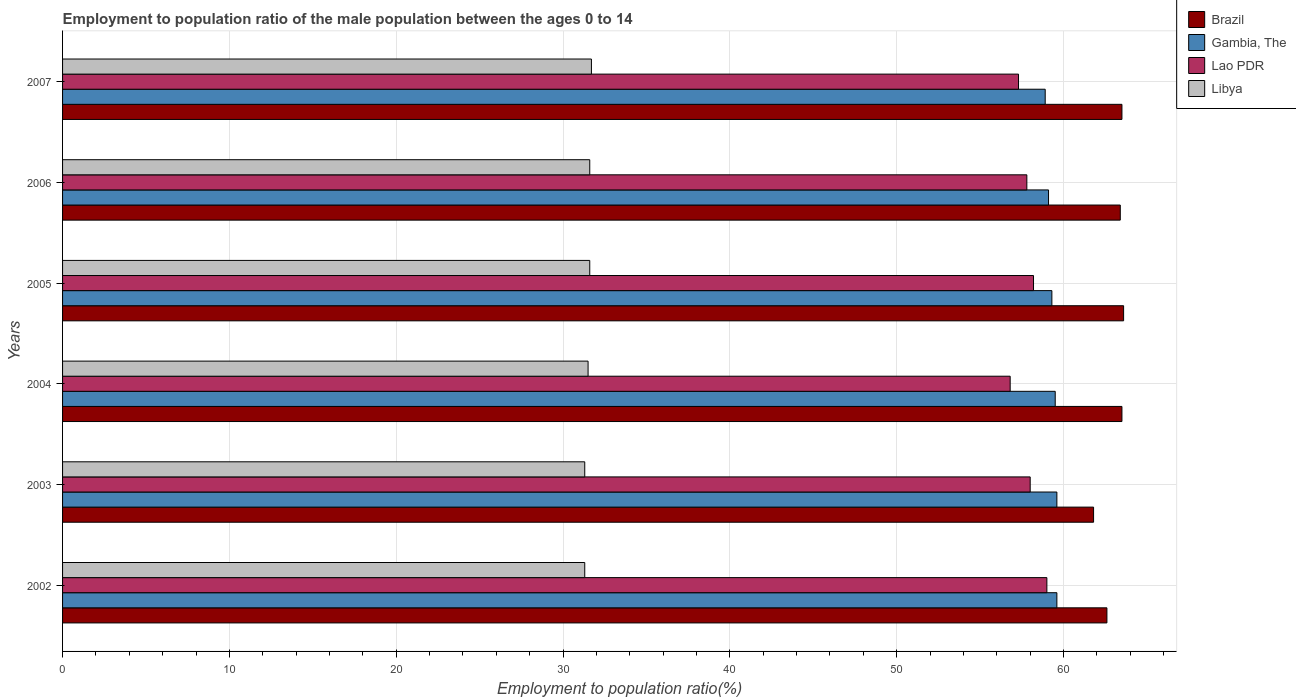How many groups of bars are there?
Your answer should be very brief. 6. How many bars are there on the 6th tick from the top?
Your response must be concise. 4. How many bars are there on the 5th tick from the bottom?
Make the answer very short. 4. What is the label of the 3rd group of bars from the top?
Your answer should be compact. 2005. What is the employment to population ratio in Gambia, The in 2005?
Your response must be concise. 59.3. Across all years, what is the maximum employment to population ratio in Brazil?
Offer a terse response. 63.6. Across all years, what is the minimum employment to population ratio in Libya?
Your answer should be compact. 31.3. What is the total employment to population ratio in Lao PDR in the graph?
Ensure brevity in your answer.  347.1. What is the difference between the employment to population ratio in Lao PDR in 2002 and that in 2004?
Provide a short and direct response. 2.2. What is the difference between the employment to population ratio in Lao PDR in 2004 and the employment to population ratio in Libya in 2007?
Ensure brevity in your answer.  25.1. What is the average employment to population ratio in Brazil per year?
Give a very brief answer. 63.07. What is the ratio of the employment to population ratio in Brazil in 2003 to that in 2005?
Your answer should be compact. 0.97. Is the employment to population ratio in Gambia, The in 2002 less than that in 2003?
Your answer should be very brief. No. Is the difference between the employment to population ratio in Brazil in 2003 and 2007 greater than the difference between the employment to population ratio in Gambia, The in 2003 and 2007?
Keep it short and to the point. No. What is the difference between the highest and the second highest employment to population ratio in Brazil?
Give a very brief answer. 0.1. What is the difference between the highest and the lowest employment to population ratio in Lao PDR?
Keep it short and to the point. 2.2. What does the 3rd bar from the top in 2007 represents?
Provide a succinct answer. Gambia, The. What does the 4th bar from the bottom in 2006 represents?
Give a very brief answer. Libya. Is it the case that in every year, the sum of the employment to population ratio in Brazil and employment to population ratio in Lao PDR is greater than the employment to population ratio in Libya?
Keep it short and to the point. Yes. How many bars are there?
Provide a succinct answer. 24. What is the difference between two consecutive major ticks on the X-axis?
Your response must be concise. 10. Does the graph contain any zero values?
Provide a succinct answer. No. Does the graph contain grids?
Your answer should be compact. Yes. How are the legend labels stacked?
Ensure brevity in your answer.  Vertical. What is the title of the graph?
Provide a succinct answer. Employment to population ratio of the male population between the ages 0 to 14. Does "Denmark" appear as one of the legend labels in the graph?
Offer a terse response. No. What is the label or title of the X-axis?
Make the answer very short. Employment to population ratio(%). What is the label or title of the Y-axis?
Keep it short and to the point. Years. What is the Employment to population ratio(%) of Brazil in 2002?
Keep it short and to the point. 62.6. What is the Employment to population ratio(%) of Gambia, The in 2002?
Provide a short and direct response. 59.6. What is the Employment to population ratio(%) in Lao PDR in 2002?
Provide a short and direct response. 59. What is the Employment to population ratio(%) in Libya in 2002?
Keep it short and to the point. 31.3. What is the Employment to population ratio(%) of Brazil in 2003?
Offer a very short reply. 61.8. What is the Employment to population ratio(%) of Gambia, The in 2003?
Give a very brief answer. 59.6. What is the Employment to population ratio(%) of Libya in 2003?
Keep it short and to the point. 31.3. What is the Employment to population ratio(%) in Brazil in 2004?
Offer a very short reply. 63.5. What is the Employment to population ratio(%) in Gambia, The in 2004?
Keep it short and to the point. 59.5. What is the Employment to population ratio(%) of Lao PDR in 2004?
Keep it short and to the point. 56.8. What is the Employment to population ratio(%) of Libya in 2004?
Provide a succinct answer. 31.5. What is the Employment to population ratio(%) in Brazil in 2005?
Your response must be concise. 63.6. What is the Employment to population ratio(%) of Gambia, The in 2005?
Provide a succinct answer. 59.3. What is the Employment to population ratio(%) of Lao PDR in 2005?
Offer a very short reply. 58.2. What is the Employment to population ratio(%) in Libya in 2005?
Provide a succinct answer. 31.6. What is the Employment to population ratio(%) of Brazil in 2006?
Make the answer very short. 63.4. What is the Employment to population ratio(%) in Gambia, The in 2006?
Your answer should be very brief. 59.1. What is the Employment to population ratio(%) in Lao PDR in 2006?
Provide a short and direct response. 57.8. What is the Employment to population ratio(%) of Libya in 2006?
Make the answer very short. 31.6. What is the Employment to population ratio(%) of Brazil in 2007?
Ensure brevity in your answer.  63.5. What is the Employment to population ratio(%) in Gambia, The in 2007?
Keep it short and to the point. 58.9. What is the Employment to population ratio(%) of Lao PDR in 2007?
Provide a short and direct response. 57.3. What is the Employment to population ratio(%) in Libya in 2007?
Keep it short and to the point. 31.7. Across all years, what is the maximum Employment to population ratio(%) of Brazil?
Your response must be concise. 63.6. Across all years, what is the maximum Employment to population ratio(%) in Gambia, The?
Provide a succinct answer. 59.6. Across all years, what is the maximum Employment to population ratio(%) in Lao PDR?
Ensure brevity in your answer.  59. Across all years, what is the maximum Employment to population ratio(%) in Libya?
Give a very brief answer. 31.7. Across all years, what is the minimum Employment to population ratio(%) in Brazil?
Your answer should be compact. 61.8. Across all years, what is the minimum Employment to population ratio(%) of Gambia, The?
Your response must be concise. 58.9. Across all years, what is the minimum Employment to population ratio(%) of Lao PDR?
Make the answer very short. 56.8. Across all years, what is the minimum Employment to population ratio(%) in Libya?
Give a very brief answer. 31.3. What is the total Employment to population ratio(%) in Brazil in the graph?
Give a very brief answer. 378.4. What is the total Employment to population ratio(%) in Gambia, The in the graph?
Make the answer very short. 356. What is the total Employment to population ratio(%) in Lao PDR in the graph?
Give a very brief answer. 347.1. What is the total Employment to population ratio(%) in Libya in the graph?
Give a very brief answer. 189. What is the difference between the Employment to population ratio(%) of Brazil in 2002 and that in 2003?
Make the answer very short. 0.8. What is the difference between the Employment to population ratio(%) of Gambia, The in 2002 and that in 2003?
Give a very brief answer. 0. What is the difference between the Employment to population ratio(%) of Libya in 2002 and that in 2003?
Offer a terse response. 0. What is the difference between the Employment to population ratio(%) in Brazil in 2002 and that in 2004?
Give a very brief answer. -0.9. What is the difference between the Employment to population ratio(%) in Gambia, The in 2002 and that in 2004?
Offer a very short reply. 0.1. What is the difference between the Employment to population ratio(%) in Libya in 2002 and that in 2004?
Give a very brief answer. -0.2. What is the difference between the Employment to population ratio(%) in Brazil in 2002 and that in 2005?
Ensure brevity in your answer.  -1. What is the difference between the Employment to population ratio(%) in Lao PDR in 2002 and that in 2005?
Give a very brief answer. 0.8. What is the difference between the Employment to population ratio(%) in Brazil in 2002 and that in 2007?
Offer a very short reply. -0.9. What is the difference between the Employment to population ratio(%) in Gambia, The in 2002 and that in 2007?
Provide a short and direct response. 0.7. What is the difference between the Employment to population ratio(%) in Lao PDR in 2003 and that in 2004?
Provide a short and direct response. 1.2. What is the difference between the Employment to population ratio(%) of Brazil in 2003 and that in 2006?
Your answer should be compact. -1.6. What is the difference between the Employment to population ratio(%) of Libya in 2003 and that in 2006?
Your answer should be very brief. -0.3. What is the difference between the Employment to population ratio(%) of Lao PDR in 2003 and that in 2007?
Provide a succinct answer. 0.7. What is the difference between the Employment to population ratio(%) of Gambia, The in 2004 and that in 2005?
Offer a terse response. 0.2. What is the difference between the Employment to population ratio(%) in Lao PDR in 2004 and that in 2005?
Make the answer very short. -1.4. What is the difference between the Employment to population ratio(%) of Brazil in 2004 and that in 2006?
Provide a short and direct response. 0.1. What is the difference between the Employment to population ratio(%) in Gambia, The in 2004 and that in 2006?
Your answer should be compact. 0.4. What is the difference between the Employment to population ratio(%) of Lao PDR in 2004 and that in 2006?
Keep it short and to the point. -1. What is the difference between the Employment to population ratio(%) of Brazil in 2004 and that in 2007?
Keep it short and to the point. 0. What is the difference between the Employment to population ratio(%) in Lao PDR in 2004 and that in 2007?
Provide a short and direct response. -0.5. What is the difference between the Employment to population ratio(%) of Brazil in 2005 and that in 2006?
Give a very brief answer. 0.2. What is the difference between the Employment to population ratio(%) of Lao PDR in 2005 and that in 2006?
Provide a short and direct response. 0.4. What is the difference between the Employment to population ratio(%) in Libya in 2005 and that in 2006?
Give a very brief answer. 0. What is the difference between the Employment to population ratio(%) in Gambia, The in 2005 and that in 2007?
Your response must be concise. 0.4. What is the difference between the Employment to population ratio(%) of Lao PDR in 2005 and that in 2007?
Make the answer very short. 0.9. What is the difference between the Employment to population ratio(%) of Libya in 2005 and that in 2007?
Your response must be concise. -0.1. What is the difference between the Employment to population ratio(%) of Libya in 2006 and that in 2007?
Offer a terse response. -0.1. What is the difference between the Employment to population ratio(%) in Brazil in 2002 and the Employment to population ratio(%) in Gambia, The in 2003?
Provide a short and direct response. 3. What is the difference between the Employment to population ratio(%) of Brazil in 2002 and the Employment to population ratio(%) of Libya in 2003?
Make the answer very short. 31.3. What is the difference between the Employment to population ratio(%) in Gambia, The in 2002 and the Employment to population ratio(%) in Lao PDR in 2003?
Give a very brief answer. 1.6. What is the difference between the Employment to population ratio(%) of Gambia, The in 2002 and the Employment to population ratio(%) of Libya in 2003?
Give a very brief answer. 28.3. What is the difference between the Employment to population ratio(%) of Lao PDR in 2002 and the Employment to population ratio(%) of Libya in 2003?
Make the answer very short. 27.7. What is the difference between the Employment to population ratio(%) of Brazil in 2002 and the Employment to population ratio(%) of Libya in 2004?
Provide a short and direct response. 31.1. What is the difference between the Employment to population ratio(%) of Gambia, The in 2002 and the Employment to population ratio(%) of Libya in 2004?
Keep it short and to the point. 28.1. What is the difference between the Employment to population ratio(%) in Lao PDR in 2002 and the Employment to population ratio(%) in Libya in 2004?
Ensure brevity in your answer.  27.5. What is the difference between the Employment to population ratio(%) in Brazil in 2002 and the Employment to population ratio(%) in Gambia, The in 2005?
Make the answer very short. 3.3. What is the difference between the Employment to population ratio(%) in Lao PDR in 2002 and the Employment to population ratio(%) in Libya in 2005?
Give a very brief answer. 27.4. What is the difference between the Employment to population ratio(%) in Brazil in 2002 and the Employment to population ratio(%) in Libya in 2006?
Your response must be concise. 31. What is the difference between the Employment to population ratio(%) of Gambia, The in 2002 and the Employment to population ratio(%) of Lao PDR in 2006?
Your answer should be very brief. 1.8. What is the difference between the Employment to population ratio(%) in Lao PDR in 2002 and the Employment to population ratio(%) in Libya in 2006?
Make the answer very short. 27.4. What is the difference between the Employment to population ratio(%) of Brazil in 2002 and the Employment to population ratio(%) of Libya in 2007?
Ensure brevity in your answer.  30.9. What is the difference between the Employment to population ratio(%) of Gambia, The in 2002 and the Employment to population ratio(%) of Lao PDR in 2007?
Provide a succinct answer. 2.3. What is the difference between the Employment to population ratio(%) of Gambia, The in 2002 and the Employment to population ratio(%) of Libya in 2007?
Make the answer very short. 27.9. What is the difference between the Employment to population ratio(%) in Lao PDR in 2002 and the Employment to population ratio(%) in Libya in 2007?
Offer a very short reply. 27.3. What is the difference between the Employment to population ratio(%) of Brazil in 2003 and the Employment to population ratio(%) of Lao PDR in 2004?
Your answer should be very brief. 5. What is the difference between the Employment to population ratio(%) of Brazil in 2003 and the Employment to population ratio(%) of Libya in 2004?
Provide a short and direct response. 30.3. What is the difference between the Employment to population ratio(%) of Gambia, The in 2003 and the Employment to population ratio(%) of Lao PDR in 2004?
Offer a very short reply. 2.8. What is the difference between the Employment to population ratio(%) of Gambia, The in 2003 and the Employment to population ratio(%) of Libya in 2004?
Your answer should be compact. 28.1. What is the difference between the Employment to population ratio(%) of Lao PDR in 2003 and the Employment to population ratio(%) of Libya in 2004?
Offer a very short reply. 26.5. What is the difference between the Employment to population ratio(%) of Brazil in 2003 and the Employment to population ratio(%) of Gambia, The in 2005?
Your response must be concise. 2.5. What is the difference between the Employment to population ratio(%) in Brazil in 2003 and the Employment to population ratio(%) in Libya in 2005?
Provide a short and direct response. 30.2. What is the difference between the Employment to population ratio(%) in Gambia, The in 2003 and the Employment to population ratio(%) in Libya in 2005?
Your answer should be very brief. 28. What is the difference between the Employment to population ratio(%) in Lao PDR in 2003 and the Employment to population ratio(%) in Libya in 2005?
Make the answer very short. 26.4. What is the difference between the Employment to population ratio(%) in Brazil in 2003 and the Employment to population ratio(%) in Gambia, The in 2006?
Your response must be concise. 2.7. What is the difference between the Employment to population ratio(%) of Brazil in 2003 and the Employment to population ratio(%) of Lao PDR in 2006?
Make the answer very short. 4. What is the difference between the Employment to population ratio(%) of Brazil in 2003 and the Employment to population ratio(%) of Libya in 2006?
Offer a terse response. 30.2. What is the difference between the Employment to population ratio(%) of Lao PDR in 2003 and the Employment to population ratio(%) of Libya in 2006?
Make the answer very short. 26.4. What is the difference between the Employment to population ratio(%) of Brazil in 2003 and the Employment to population ratio(%) of Libya in 2007?
Make the answer very short. 30.1. What is the difference between the Employment to population ratio(%) in Gambia, The in 2003 and the Employment to population ratio(%) in Lao PDR in 2007?
Ensure brevity in your answer.  2.3. What is the difference between the Employment to population ratio(%) of Gambia, The in 2003 and the Employment to population ratio(%) of Libya in 2007?
Your response must be concise. 27.9. What is the difference between the Employment to population ratio(%) in Lao PDR in 2003 and the Employment to population ratio(%) in Libya in 2007?
Your answer should be compact. 26.3. What is the difference between the Employment to population ratio(%) in Brazil in 2004 and the Employment to population ratio(%) in Gambia, The in 2005?
Offer a very short reply. 4.2. What is the difference between the Employment to population ratio(%) of Brazil in 2004 and the Employment to population ratio(%) of Libya in 2005?
Give a very brief answer. 31.9. What is the difference between the Employment to population ratio(%) in Gambia, The in 2004 and the Employment to population ratio(%) in Lao PDR in 2005?
Give a very brief answer. 1.3. What is the difference between the Employment to population ratio(%) of Gambia, The in 2004 and the Employment to population ratio(%) of Libya in 2005?
Provide a succinct answer. 27.9. What is the difference between the Employment to population ratio(%) of Lao PDR in 2004 and the Employment to population ratio(%) of Libya in 2005?
Ensure brevity in your answer.  25.2. What is the difference between the Employment to population ratio(%) in Brazil in 2004 and the Employment to population ratio(%) in Gambia, The in 2006?
Ensure brevity in your answer.  4.4. What is the difference between the Employment to population ratio(%) in Brazil in 2004 and the Employment to population ratio(%) in Lao PDR in 2006?
Provide a succinct answer. 5.7. What is the difference between the Employment to population ratio(%) in Brazil in 2004 and the Employment to population ratio(%) in Libya in 2006?
Keep it short and to the point. 31.9. What is the difference between the Employment to population ratio(%) in Gambia, The in 2004 and the Employment to population ratio(%) in Libya in 2006?
Give a very brief answer. 27.9. What is the difference between the Employment to population ratio(%) of Lao PDR in 2004 and the Employment to population ratio(%) of Libya in 2006?
Your answer should be very brief. 25.2. What is the difference between the Employment to population ratio(%) in Brazil in 2004 and the Employment to population ratio(%) in Gambia, The in 2007?
Offer a very short reply. 4.6. What is the difference between the Employment to population ratio(%) of Brazil in 2004 and the Employment to population ratio(%) of Lao PDR in 2007?
Provide a succinct answer. 6.2. What is the difference between the Employment to population ratio(%) of Brazil in 2004 and the Employment to population ratio(%) of Libya in 2007?
Provide a succinct answer. 31.8. What is the difference between the Employment to population ratio(%) of Gambia, The in 2004 and the Employment to population ratio(%) of Lao PDR in 2007?
Make the answer very short. 2.2. What is the difference between the Employment to population ratio(%) of Gambia, The in 2004 and the Employment to population ratio(%) of Libya in 2007?
Your response must be concise. 27.8. What is the difference between the Employment to population ratio(%) of Lao PDR in 2004 and the Employment to population ratio(%) of Libya in 2007?
Your answer should be very brief. 25.1. What is the difference between the Employment to population ratio(%) in Brazil in 2005 and the Employment to population ratio(%) in Libya in 2006?
Provide a succinct answer. 32. What is the difference between the Employment to population ratio(%) in Gambia, The in 2005 and the Employment to population ratio(%) in Lao PDR in 2006?
Keep it short and to the point. 1.5. What is the difference between the Employment to population ratio(%) of Gambia, The in 2005 and the Employment to population ratio(%) of Libya in 2006?
Ensure brevity in your answer.  27.7. What is the difference between the Employment to population ratio(%) in Lao PDR in 2005 and the Employment to population ratio(%) in Libya in 2006?
Provide a succinct answer. 26.6. What is the difference between the Employment to population ratio(%) of Brazil in 2005 and the Employment to population ratio(%) of Lao PDR in 2007?
Offer a terse response. 6.3. What is the difference between the Employment to population ratio(%) of Brazil in 2005 and the Employment to population ratio(%) of Libya in 2007?
Give a very brief answer. 31.9. What is the difference between the Employment to population ratio(%) of Gambia, The in 2005 and the Employment to population ratio(%) of Libya in 2007?
Give a very brief answer. 27.6. What is the difference between the Employment to population ratio(%) of Lao PDR in 2005 and the Employment to population ratio(%) of Libya in 2007?
Make the answer very short. 26.5. What is the difference between the Employment to population ratio(%) in Brazil in 2006 and the Employment to population ratio(%) in Gambia, The in 2007?
Your response must be concise. 4.5. What is the difference between the Employment to population ratio(%) in Brazil in 2006 and the Employment to population ratio(%) in Lao PDR in 2007?
Offer a terse response. 6.1. What is the difference between the Employment to population ratio(%) of Brazil in 2006 and the Employment to population ratio(%) of Libya in 2007?
Offer a terse response. 31.7. What is the difference between the Employment to population ratio(%) in Gambia, The in 2006 and the Employment to population ratio(%) in Libya in 2007?
Give a very brief answer. 27.4. What is the difference between the Employment to population ratio(%) of Lao PDR in 2006 and the Employment to population ratio(%) of Libya in 2007?
Make the answer very short. 26.1. What is the average Employment to population ratio(%) of Brazil per year?
Keep it short and to the point. 63.07. What is the average Employment to population ratio(%) of Gambia, The per year?
Your answer should be very brief. 59.33. What is the average Employment to population ratio(%) in Lao PDR per year?
Keep it short and to the point. 57.85. What is the average Employment to population ratio(%) in Libya per year?
Offer a terse response. 31.5. In the year 2002, what is the difference between the Employment to population ratio(%) in Brazil and Employment to population ratio(%) in Gambia, The?
Ensure brevity in your answer.  3. In the year 2002, what is the difference between the Employment to population ratio(%) of Brazil and Employment to population ratio(%) of Lao PDR?
Provide a succinct answer. 3.6. In the year 2002, what is the difference between the Employment to population ratio(%) of Brazil and Employment to population ratio(%) of Libya?
Ensure brevity in your answer.  31.3. In the year 2002, what is the difference between the Employment to population ratio(%) in Gambia, The and Employment to population ratio(%) in Lao PDR?
Keep it short and to the point. 0.6. In the year 2002, what is the difference between the Employment to population ratio(%) in Gambia, The and Employment to population ratio(%) in Libya?
Give a very brief answer. 28.3. In the year 2002, what is the difference between the Employment to population ratio(%) of Lao PDR and Employment to population ratio(%) of Libya?
Keep it short and to the point. 27.7. In the year 2003, what is the difference between the Employment to population ratio(%) in Brazil and Employment to population ratio(%) in Gambia, The?
Keep it short and to the point. 2.2. In the year 2003, what is the difference between the Employment to population ratio(%) in Brazil and Employment to population ratio(%) in Libya?
Provide a succinct answer. 30.5. In the year 2003, what is the difference between the Employment to population ratio(%) of Gambia, The and Employment to population ratio(%) of Lao PDR?
Provide a succinct answer. 1.6. In the year 2003, what is the difference between the Employment to population ratio(%) of Gambia, The and Employment to population ratio(%) of Libya?
Your answer should be compact. 28.3. In the year 2003, what is the difference between the Employment to population ratio(%) of Lao PDR and Employment to population ratio(%) of Libya?
Ensure brevity in your answer.  26.7. In the year 2004, what is the difference between the Employment to population ratio(%) of Brazil and Employment to population ratio(%) of Gambia, The?
Give a very brief answer. 4. In the year 2004, what is the difference between the Employment to population ratio(%) of Lao PDR and Employment to population ratio(%) of Libya?
Offer a terse response. 25.3. In the year 2005, what is the difference between the Employment to population ratio(%) in Gambia, The and Employment to population ratio(%) in Lao PDR?
Provide a short and direct response. 1.1. In the year 2005, what is the difference between the Employment to population ratio(%) of Gambia, The and Employment to population ratio(%) of Libya?
Give a very brief answer. 27.7. In the year 2005, what is the difference between the Employment to population ratio(%) of Lao PDR and Employment to population ratio(%) of Libya?
Ensure brevity in your answer.  26.6. In the year 2006, what is the difference between the Employment to population ratio(%) of Brazil and Employment to population ratio(%) of Gambia, The?
Make the answer very short. 4.3. In the year 2006, what is the difference between the Employment to population ratio(%) in Brazil and Employment to population ratio(%) in Lao PDR?
Make the answer very short. 5.6. In the year 2006, what is the difference between the Employment to population ratio(%) of Brazil and Employment to population ratio(%) of Libya?
Keep it short and to the point. 31.8. In the year 2006, what is the difference between the Employment to population ratio(%) of Lao PDR and Employment to population ratio(%) of Libya?
Provide a succinct answer. 26.2. In the year 2007, what is the difference between the Employment to population ratio(%) in Brazil and Employment to population ratio(%) in Libya?
Give a very brief answer. 31.8. In the year 2007, what is the difference between the Employment to population ratio(%) in Gambia, The and Employment to population ratio(%) in Libya?
Ensure brevity in your answer.  27.2. In the year 2007, what is the difference between the Employment to population ratio(%) in Lao PDR and Employment to population ratio(%) in Libya?
Your answer should be compact. 25.6. What is the ratio of the Employment to population ratio(%) of Brazil in 2002 to that in 2003?
Your response must be concise. 1.01. What is the ratio of the Employment to population ratio(%) in Lao PDR in 2002 to that in 2003?
Give a very brief answer. 1.02. What is the ratio of the Employment to population ratio(%) of Brazil in 2002 to that in 2004?
Your response must be concise. 0.99. What is the ratio of the Employment to population ratio(%) of Lao PDR in 2002 to that in 2004?
Keep it short and to the point. 1.04. What is the ratio of the Employment to population ratio(%) of Libya in 2002 to that in 2004?
Give a very brief answer. 0.99. What is the ratio of the Employment to population ratio(%) in Brazil in 2002 to that in 2005?
Your answer should be very brief. 0.98. What is the ratio of the Employment to population ratio(%) in Gambia, The in 2002 to that in 2005?
Your response must be concise. 1.01. What is the ratio of the Employment to population ratio(%) of Lao PDR in 2002 to that in 2005?
Provide a short and direct response. 1.01. What is the ratio of the Employment to population ratio(%) in Libya in 2002 to that in 2005?
Make the answer very short. 0.99. What is the ratio of the Employment to population ratio(%) in Brazil in 2002 to that in 2006?
Give a very brief answer. 0.99. What is the ratio of the Employment to population ratio(%) of Gambia, The in 2002 to that in 2006?
Your answer should be very brief. 1.01. What is the ratio of the Employment to population ratio(%) in Lao PDR in 2002 to that in 2006?
Your response must be concise. 1.02. What is the ratio of the Employment to population ratio(%) in Brazil in 2002 to that in 2007?
Provide a short and direct response. 0.99. What is the ratio of the Employment to population ratio(%) of Gambia, The in 2002 to that in 2007?
Give a very brief answer. 1.01. What is the ratio of the Employment to population ratio(%) in Lao PDR in 2002 to that in 2007?
Your answer should be very brief. 1.03. What is the ratio of the Employment to population ratio(%) in Libya in 2002 to that in 2007?
Ensure brevity in your answer.  0.99. What is the ratio of the Employment to population ratio(%) in Brazil in 2003 to that in 2004?
Keep it short and to the point. 0.97. What is the ratio of the Employment to population ratio(%) of Lao PDR in 2003 to that in 2004?
Your answer should be compact. 1.02. What is the ratio of the Employment to population ratio(%) in Libya in 2003 to that in 2004?
Offer a terse response. 0.99. What is the ratio of the Employment to population ratio(%) of Brazil in 2003 to that in 2005?
Provide a succinct answer. 0.97. What is the ratio of the Employment to population ratio(%) of Gambia, The in 2003 to that in 2005?
Give a very brief answer. 1.01. What is the ratio of the Employment to population ratio(%) of Brazil in 2003 to that in 2006?
Give a very brief answer. 0.97. What is the ratio of the Employment to population ratio(%) of Gambia, The in 2003 to that in 2006?
Ensure brevity in your answer.  1.01. What is the ratio of the Employment to population ratio(%) in Lao PDR in 2003 to that in 2006?
Offer a terse response. 1. What is the ratio of the Employment to population ratio(%) in Brazil in 2003 to that in 2007?
Your response must be concise. 0.97. What is the ratio of the Employment to population ratio(%) in Gambia, The in 2003 to that in 2007?
Provide a succinct answer. 1.01. What is the ratio of the Employment to population ratio(%) in Lao PDR in 2003 to that in 2007?
Your answer should be compact. 1.01. What is the ratio of the Employment to population ratio(%) in Libya in 2003 to that in 2007?
Provide a succinct answer. 0.99. What is the ratio of the Employment to population ratio(%) of Brazil in 2004 to that in 2005?
Provide a short and direct response. 1. What is the ratio of the Employment to population ratio(%) of Lao PDR in 2004 to that in 2005?
Your answer should be very brief. 0.98. What is the ratio of the Employment to population ratio(%) in Libya in 2004 to that in 2005?
Make the answer very short. 1. What is the ratio of the Employment to population ratio(%) in Brazil in 2004 to that in 2006?
Give a very brief answer. 1. What is the ratio of the Employment to population ratio(%) in Gambia, The in 2004 to that in 2006?
Ensure brevity in your answer.  1.01. What is the ratio of the Employment to population ratio(%) in Lao PDR in 2004 to that in 2006?
Provide a short and direct response. 0.98. What is the ratio of the Employment to population ratio(%) in Brazil in 2004 to that in 2007?
Your answer should be compact. 1. What is the ratio of the Employment to population ratio(%) of Gambia, The in 2004 to that in 2007?
Offer a terse response. 1.01. What is the ratio of the Employment to population ratio(%) of Lao PDR in 2004 to that in 2007?
Offer a terse response. 0.99. What is the ratio of the Employment to population ratio(%) in Brazil in 2005 to that in 2006?
Provide a succinct answer. 1. What is the ratio of the Employment to population ratio(%) in Gambia, The in 2005 to that in 2006?
Your answer should be compact. 1. What is the ratio of the Employment to population ratio(%) in Lao PDR in 2005 to that in 2006?
Your answer should be very brief. 1.01. What is the ratio of the Employment to population ratio(%) in Libya in 2005 to that in 2006?
Provide a succinct answer. 1. What is the ratio of the Employment to population ratio(%) in Brazil in 2005 to that in 2007?
Your answer should be very brief. 1. What is the ratio of the Employment to population ratio(%) of Gambia, The in 2005 to that in 2007?
Your response must be concise. 1.01. What is the ratio of the Employment to population ratio(%) of Lao PDR in 2005 to that in 2007?
Your response must be concise. 1.02. What is the ratio of the Employment to population ratio(%) in Libya in 2005 to that in 2007?
Offer a terse response. 1. What is the ratio of the Employment to population ratio(%) in Lao PDR in 2006 to that in 2007?
Provide a short and direct response. 1.01. What is the difference between the highest and the second highest Employment to population ratio(%) of Brazil?
Offer a very short reply. 0.1. What is the difference between the highest and the second highest Employment to population ratio(%) of Gambia, The?
Your answer should be very brief. 0. What is the difference between the highest and the second highest Employment to population ratio(%) in Lao PDR?
Provide a succinct answer. 0.8. What is the difference between the highest and the lowest Employment to population ratio(%) of Gambia, The?
Provide a short and direct response. 0.7. What is the difference between the highest and the lowest Employment to population ratio(%) in Libya?
Keep it short and to the point. 0.4. 